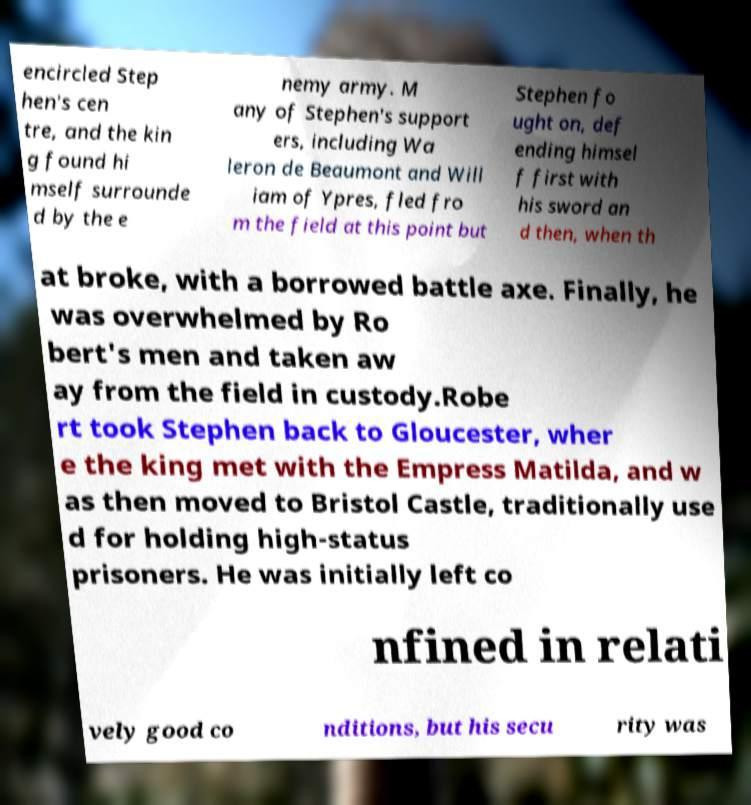Can you read and provide the text displayed in the image?This photo seems to have some interesting text. Can you extract and type it out for me? encircled Step hen's cen tre, and the kin g found hi mself surrounde d by the e nemy army. M any of Stephen's support ers, including Wa leron de Beaumont and Will iam of Ypres, fled fro m the field at this point but Stephen fo ught on, def ending himsel f first with his sword an d then, when th at broke, with a borrowed battle axe. Finally, he was overwhelmed by Ro bert's men and taken aw ay from the field in custody.Robe rt took Stephen back to Gloucester, wher e the king met with the Empress Matilda, and w as then moved to Bristol Castle, traditionally use d for holding high-status prisoners. He was initially left co nfined in relati vely good co nditions, but his secu rity was 